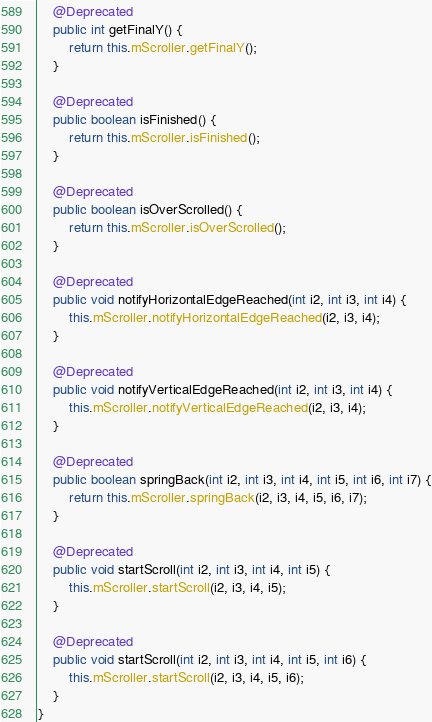<code> <loc_0><loc_0><loc_500><loc_500><_Java_>    @Deprecated
    public int getFinalY() {
        return this.mScroller.getFinalY();
    }

    @Deprecated
    public boolean isFinished() {
        return this.mScroller.isFinished();
    }

    @Deprecated
    public boolean isOverScrolled() {
        return this.mScroller.isOverScrolled();
    }

    @Deprecated
    public void notifyHorizontalEdgeReached(int i2, int i3, int i4) {
        this.mScroller.notifyHorizontalEdgeReached(i2, i3, i4);
    }

    @Deprecated
    public void notifyVerticalEdgeReached(int i2, int i3, int i4) {
        this.mScroller.notifyVerticalEdgeReached(i2, i3, i4);
    }

    @Deprecated
    public boolean springBack(int i2, int i3, int i4, int i5, int i6, int i7) {
        return this.mScroller.springBack(i2, i3, i4, i5, i6, i7);
    }

    @Deprecated
    public void startScroll(int i2, int i3, int i4, int i5) {
        this.mScroller.startScroll(i2, i3, i4, i5);
    }

    @Deprecated
    public void startScroll(int i2, int i3, int i4, int i5, int i6) {
        this.mScroller.startScroll(i2, i3, i4, i5, i6);
    }
}
</code> 